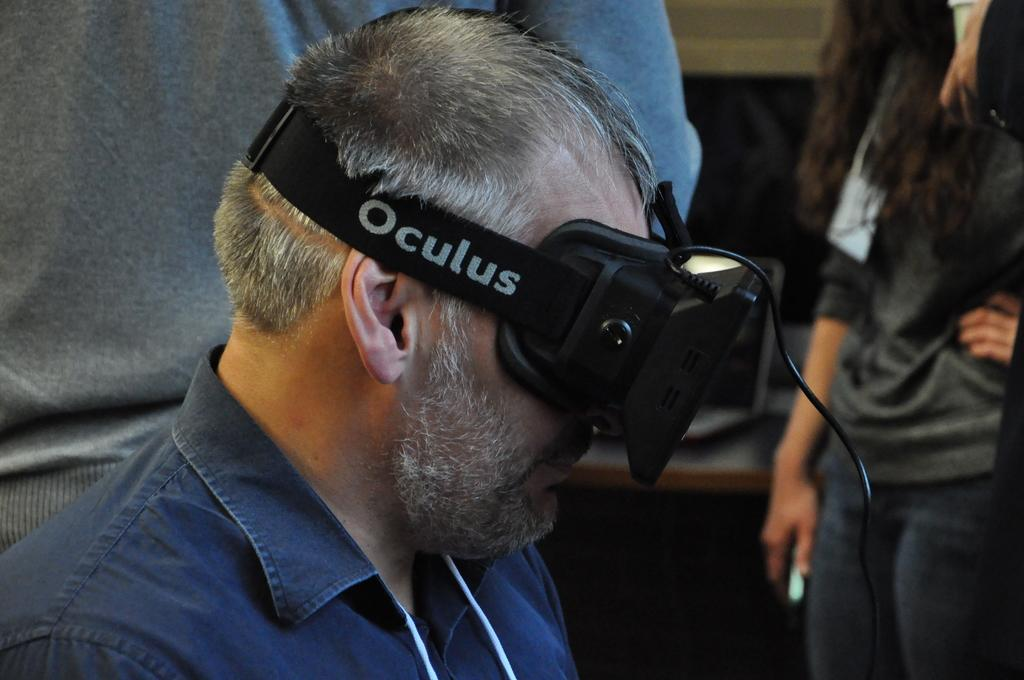What is the person in the center of the image wearing? The person in the center of the image is wearing an oculus. What can be seen in the background of the image? There are other people standing in the background, as well as a table and a wall. How many people are visible in the image? There is one person wearing an oculus in the center of the image, and other people can be seen in the background. What type of winter clothing is the person wearing in the image? The person in the image is not wearing any winter clothing, as the facts provided do not mention any such items. 